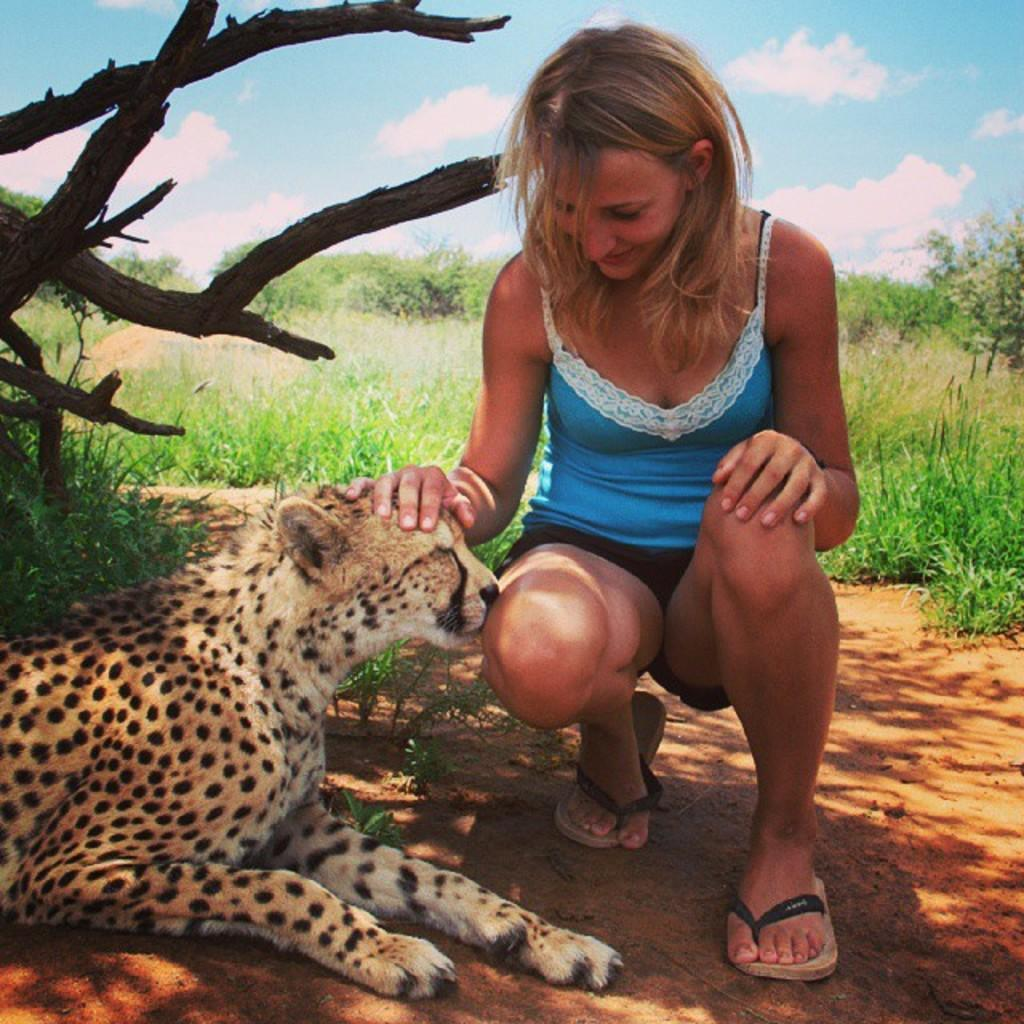Who is in the image? There is a woman in the image. What is the woman wearing? The woman is wearing a blue T-shirt. What position is the woman in? The woman is in the squat position. What animal is on the ground in the image? There is a cheetah on the ground in the image. What type of vegetation is visible in the background of the image? There is grass and trees in the background of the image. What part of the natural environment is visible in the image? The sky is visible in the background of the image, and clouds are present in the sky. What type of approval does the woman need to take the trip with the cheetah in the image? There is no mention of a trip or any need for approval in the image. The woman is in a squat position, and the cheetah is on the ground. 